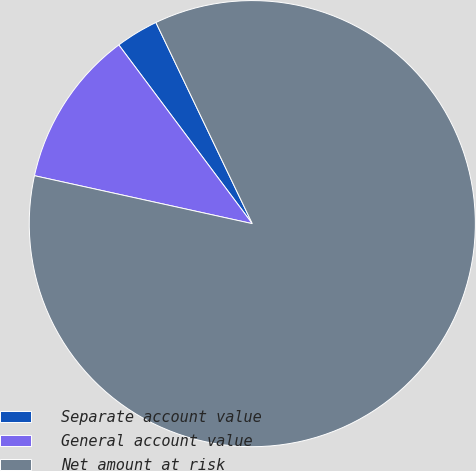<chart> <loc_0><loc_0><loc_500><loc_500><pie_chart><fcel>Separate account value<fcel>General account value<fcel>Net amount at risk<nl><fcel>3.1%<fcel>11.34%<fcel>85.56%<nl></chart> 